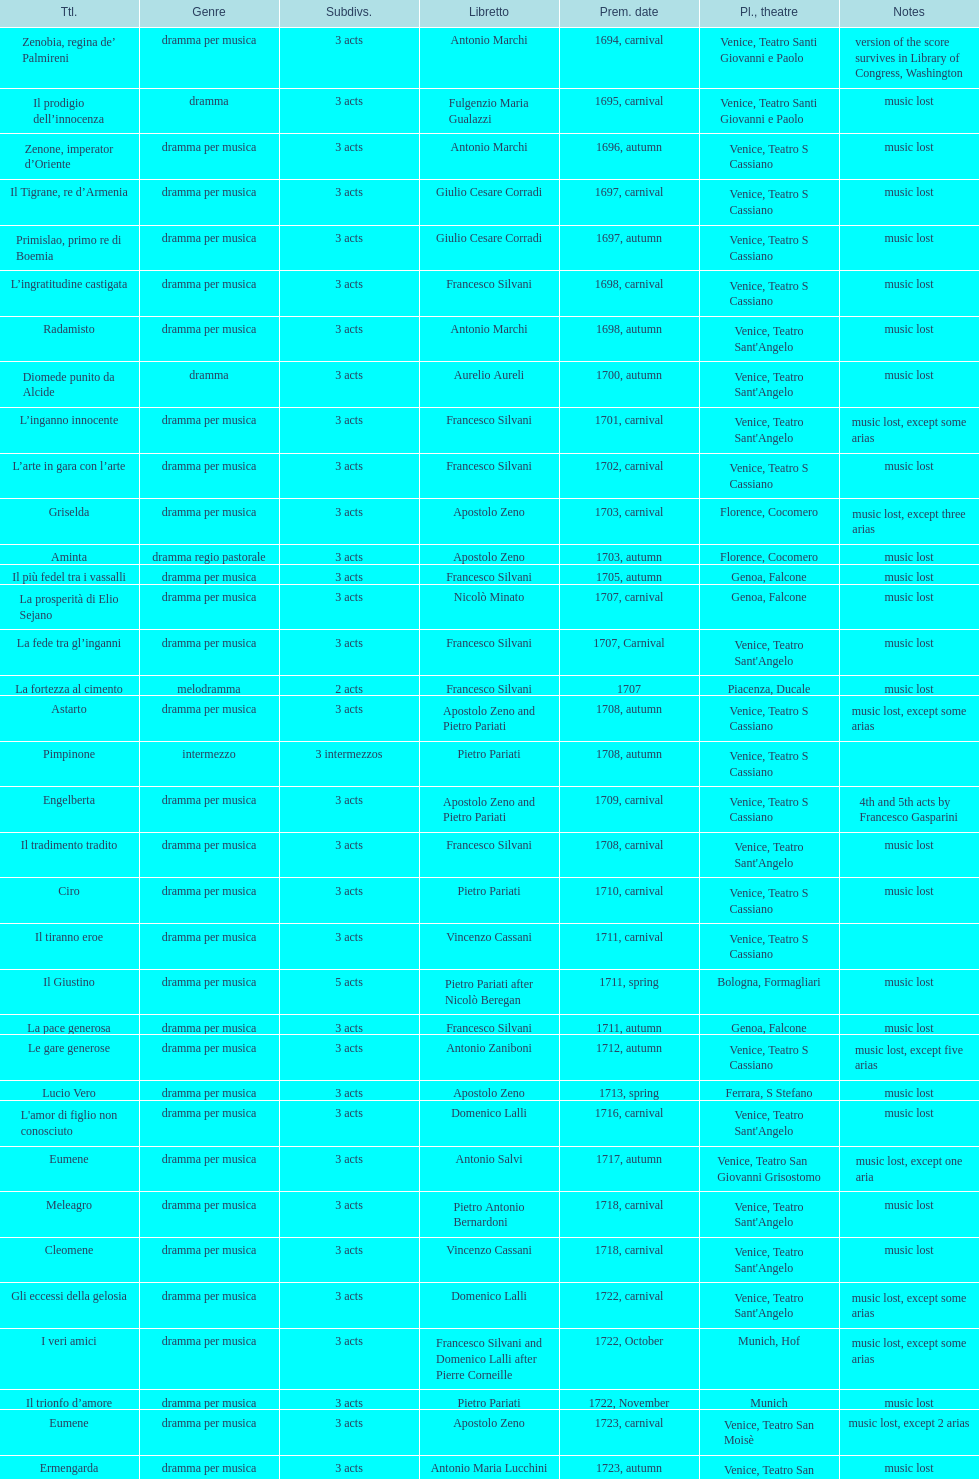What number of acts does il giustino have? 5. 